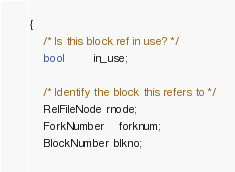<code> <loc_0><loc_0><loc_500><loc_500><_C_>{
	/* Is this block ref in use? */
	bool		in_use;

	/* Identify the block this refers to */
	RelFileNode rnode;
	ForkNumber	forknum;
	BlockNumber blkno;
</code> 